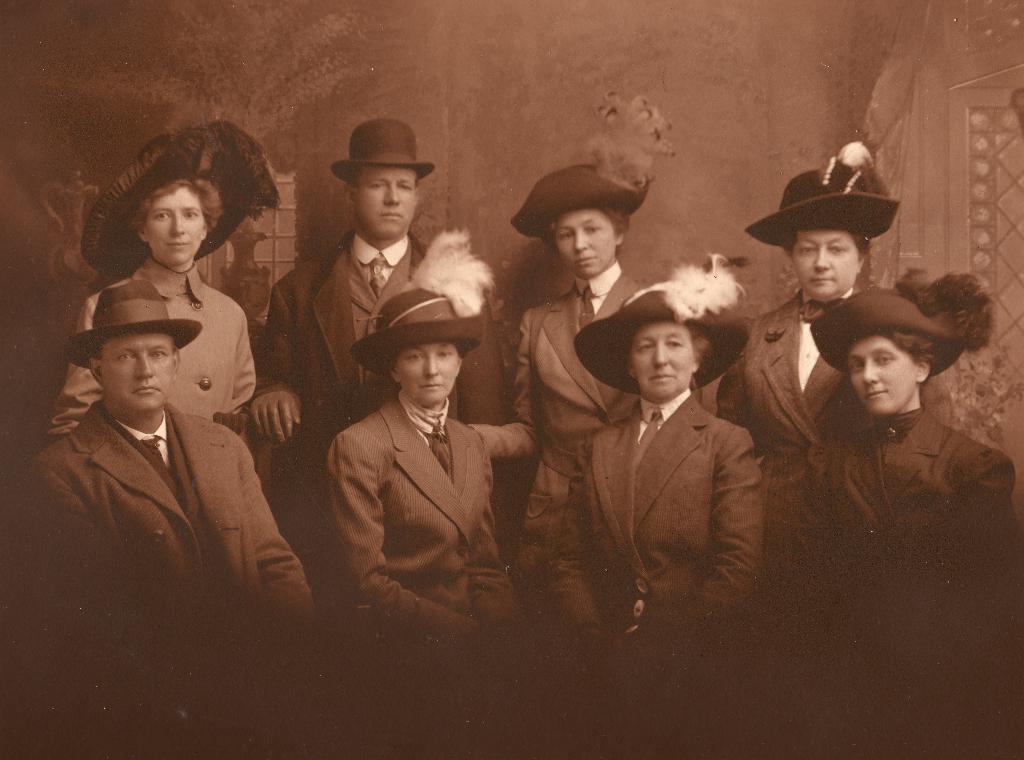How would you summarize this image in a sentence or two? In this picture, we can see a few people with hats, and we can see the background with wall and some objects. 